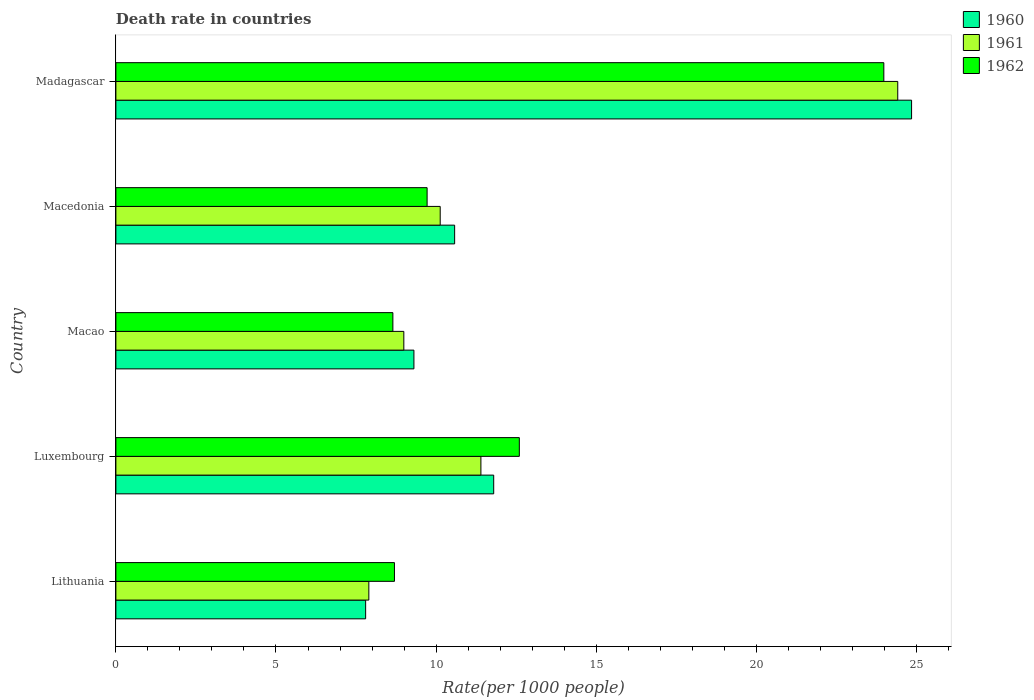Are the number of bars on each tick of the Y-axis equal?
Keep it short and to the point. Yes. How many bars are there on the 2nd tick from the top?
Your answer should be compact. 3. How many bars are there on the 4th tick from the bottom?
Give a very brief answer. 3. What is the label of the 2nd group of bars from the top?
Provide a short and direct response. Macedonia. In how many cases, is the number of bars for a given country not equal to the number of legend labels?
Offer a terse response. 0. What is the death rate in 1962 in Macao?
Offer a very short reply. 8.65. Across all countries, what is the maximum death rate in 1961?
Make the answer very short. 24.42. Across all countries, what is the minimum death rate in 1962?
Offer a very short reply. 8.65. In which country was the death rate in 1962 maximum?
Your answer should be very brief. Madagascar. In which country was the death rate in 1962 minimum?
Your answer should be compact. Macao. What is the total death rate in 1960 in the graph?
Your response must be concise. 64.34. What is the difference between the death rate in 1961 in Lithuania and that in Madagascar?
Offer a terse response. -16.52. What is the difference between the death rate in 1962 in Macao and the death rate in 1960 in Luxembourg?
Make the answer very short. -3.15. What is the average death rate in 1962 per country?
Your answer should be compact. 12.73. What is the difference between the death rate in 1962 and death rate in 1961 in Macedonia?
Make the answer very short. -0.41. In how many countries, is the death rate in 1962 greater than 3 ?
Offer a very short reply. 5. What is the ratio of the death rate in 1962 in Luxembourg to that in Madagascar?
Offer a terse response. 0.53. What is the difference between the highest and the second highest death rate in 1962?
Your response must be concise. 11.38. What is the difference between the highest and the lowest death rate in 1960?
Your answer should be very brief. 17.05. Is the sum of the death rate in 1961 in Luxembourg and Macedonia greater than the maximum death rate in 1962 across all countries?
Offer a terse response. No. What does the 1st bar from the bottom in Madagascar represents?
Ensure brevity in your answer.  1960. Is it the case that in every country, the sum of the death rate in 1960 and death rate in 1962 is greater than the death rate in 1961?
Ensure brevity in your answer.  Yes. How many bars are there?
Keep it short and to the point. 15. How many countries are there in the graph?
Ensure brevity in your answer.  5. What is the difference between two consecutive major ticks on the X-axis?
Your answer should be compact. 5. Are the values on the major ticks of X-axis written in scientific E-notation?
Provide a short and direct response. No. Does the graph contain any zero values?
Keep it short and to the point. No. Does the graph contain grids?
Keep it short and to the point. No. Where does the legend appear in the graph?
Your answer should be compact. Top right. What is the title of the graph?
Your answer should be very brief. Death rate in countries. Does "1962" appear as one of the legend labels in the graph?
Keep it short and to the point. Yes. What is the label or title of the X-axis?
Your response must be concise. Rate(per 1000 people). What is the label or title of the Y-axis?
Offer a terse response. Country. What is the Rate(per 1000 people) of 1961 in Lithuania?
Provide a succinct answer. 7.9. What is the Rate(per 1000 people) of 1960 in Luxembourg?
Offer a terse response. 11.8. What is the Rate(per 1000 people) in 1960 in Macao?
Provide a succinct answer. 9.31. What is the Rate(per 1000 people) in 1961 in Macao?
Your answer should be very brief. 8.99. What is the Rate(per 1000 people) in 1962 in Macao?
Ensure brevity in your answer.  8.65. What is the Rate(per 1000 people) of 1960 in Macedonia?
Your answer should be compact. 10.58. What is the Rate(per 1000 people) in 1961 in Macedonia?
Your answer should be compact. 10.13. What is the Rate(per 1000 people) of 1962 in Macedonia?
Ensure brevity in your answer.  9.72. What is the Rate(per 1000 people) in 1960 in Madagascar?
Ensure brevity in your answer.  24.85. What is the Rate(per 1000 people) of 1961 in Madagascar?
Provide a short and direct response. 24.42. What is the Rate(per 1000 people) in 1962 in Madagascar?
Make the answer very short. 23.98. Across all countries, what is the maximum Rate(per 1000 people) of 1960?
Offer a very short reply. 24.85. Across all countries, what is the maximum Rate(per 1000 people) in 1961?
Give a very brief answer. 24.42. Across all countries, what is the maximum Rate(per 1000 people) of 1962?
Provide a short and direct response. 23.98. Across all countries, what is the minimum Rate(per 1000 people) of 1960?
Your answer should be very brief. 7.8. Across all countries, what is the minimum Rate(per 1000 people) of 1961?
Offer a very short reply. 7.9. Across all countries, what is the minimum Rate(per 1000 people) of 1962?
Offer a very short reply. 8.65. What is the total Rate(per 1000 people) of 1960 in the graph?
Offer a terse response. 64.34. What is the total Rate(per 1000 people) in 1961 in the graph?
Provide a short and direct response. 62.84. What is the total Rate(per 1000 people) of 1962 in the graph?
Offer a very short reply. 63.66. What is the difference between the Rate(per 1000 people) in 1961 in Lithuania and that in Luxembourg?
Your response must be concise. -3.5. What is the difference between the Rate(per 1000 people) in 1960 in Lithuania and that in Macao?
Provide a succinct answer. -1.51. What is the difference between the Rate(per 1000 people) in 1961 in Lithuania and that in Macao?
Give a very brief answer. -1.09. What is the difference between the Rate(per 1000 people) of 1962 in Lithuania and that in Macao?
Your response must be concise. 0.05. What is the difference between the Rate(per 1000 people) of 1960 in Lithuania and that in Macedonia?
Provide a short and direct response. -2.78. What is the difference between the Rate(per 1000 people) in 1961 in Lithuania and that in Macedonia?
Your response must be concise. -2.23. What is the difference between the Rate(per 1000 people) in 1962 in Lithuania and that in Macedonia?
Offer a terse response. -1.02. What is the difference between the Rate(per 1000 people) in 1960 in Lithuania and that in Madagascar?
Make the answer very short. -17.05. What is the difference between the Rate(per 1000 people) of 1961 in Lithuania and that in Madagascar?
Give a very brief answer. -16.52. What is the difference between the Rate(per 1000 people) of 1962 in Lithuania and that in Madagascar?
Your answer should be compact. -15.28. What is the difference between the Rate(per 1000 people) in 1960 in Luxembourg and that in Macao?
Keep it short and to the point. 2.49. What is the difference between the Rate(per 1000 people) in 1961 in Luxembourg and that in Macao?
Offer a very short reply. 2.41. What is the difference between the Rate(per 1000 people) of 1962 in Luxembourg and that in Macao?
Keep it short and to the point. 3.95. What is the difference between the Rate(per 1000 people) of 1960 in Luxembourg and that in Macedonia?
Offer a very short reply. 1.22. What is the difference between the Rate(per 1000 people) in 1961 in Luxembourg and that in Macedonia?
Make the answer very short. 1.27. What is the difference between the Rate(per 1000 people) of 1962 in Luxembourg and that in Macedonia?
Provide a succinct answer. 2.88. What is the difference between the Rate(per 1000 people) in 1960 in Luxembourg and that in Madagascar?
Offer a terse response. -13.05. What is the difference between the Rate(per 1000 people) in 1961 in Luxembourg and that in Madagascar?
Your answer should be compact. -13.02. What is the difference between the Rate(per 1000 people) of 1962 in Luxembourg and that in Madagascar?
Your response must be concise. -11.38. What is the difference between the Rate(per 1000 people) of 1960 in Macao and that in Macedonia?
Your answer should be very brief. -1.27. What is the difference between the Rate(per 1000 people) of 1961 in Macao and that in Macedonia?
Provide a succinct answer. -1.14. What is the difference between the Rate(per 1000 people) of 1962 in Macao and that in Macedonia?
Offer a terse response. -1.07. What is the difference between the Rate(per 1000 people) in 1960 in Macao and that in Madagascar?
Your answer should be compact. -15.54. What is the difference between the Rate(per 1000 people) of 1961 in Macao and that in Madagascar?
Provide a short and direct response. -15.43. What is the difference between the Rate(per 1000 people) in 1962 in Macao and that in Madagascar?
Your answer should be compact. -15.33. What is the difference between the Rate(per 1000 people) of 1960 in Macedonia and that in Madagascar?
Ensure brevity in your answer.  -14.27. What is the difference between the Rate(per 1000 people) of 1961 in Macedonia and that in Madagascar?
Your response must be concise. -14.29. What is the difference between the Rate(per 1000 people) of 1962 in Macedonia and that in Madagascar?
Keep it short and to the point. -14.26. What is the difference between the Rate(per 1000 people) of 1960 in Lithuania and the Rate(per 1000 people) of 1961 in Luxembourg?
Provide a succinct answer. -3.6. What is the difference between the Rate(per 1000 people) in 1960 in Lithuania and the Rate(per 1000 people) in 1962 in Luxembourg?
Your answer should be compact. -4.8. What is the difference between the Rate(per 1000 people) in 1961 in Lithuania and the Rate(per 1000 people) in 1962 in Luxembourg?
Make the answer very short. -4.7. What is the difference between the Rate(per 1000 people) in 1960 in Lithuania and the Rate(per 1000 people) in 1961 in Macao?
Your answer should be compact. -1.19. What is the difference between the Rate(per 1000 people) in 1960 in Lithuania and the Rate(per 1000 people) in 1962 in Macao?
Give a very brief answer. -0.85. What is the difference between the Rate(per 1000 people) of 1961 in Lithuania and the Rate(per 1000 people) of 1962 in Macao?
Offer a terse response. -0.75. What is the difference between the Rate(per 1000 people) of 1960 in Lithuania and the Rate(per 1000 people) of 1961 in Macedonia?
Your response must be concise. -2.33. What is the difference between the Rate(per 1000 people) of 1960 in Lithuania and the Rate(per 1000 people) of 1962 in Macedonia?
Provide a succinct answer. -1.92. What is the difference between the Rate(per 1000 people) of 1961 in Lithuania and the Rate(per 1000 people) of 1962 in Macedonia?
Provide a short and direct response. -1.82. What is the difference between the Rate(per 1000 people) in 1960 in Lithuania and the Rate(per 1000 people) in 1961 in Madagascar?
Provide a succinct answer. -16.62. What is the difference between the Rate(per 1000 people) of 1960 in Lithuania and the Rate(per 1000 people) of 1962 in Madagascar?
Your answer should be very brief. -16.18. What is the difference between the Rate(per 1000 people) of 1961 in Lithuania and the Rate(per 1000 people) of 1962 in Madagascar?
Your answer should be very brief. -16.08. What is the difference between the Rate(per 1000 people) of 1960 in Luxembourg and the Rate(per 1000 people) of 1961 in Macao?
Ensure brevity in your answer.  2.81. What is the difference between the Rate(per 1000 people) of 1960 in Luxembourg and the Rate(per 1000 people) of 1962 in Macao?
Your response must be concise. 3.15. What is the difference between the Rate(per 1000 people) of 1961 in Luxembourg and the Rate(per 1000 people) of 1962 in Macao?
Provide a short and direct response. 2.75. What is the difference between the Rate(per 1000 people) of 1960 in Luxembourg and the Rate(per 1000 people) of 1961 in Macedonia?
Provide a short and direct response. 1.67. What is the difference between the Rate(per 1000 people) of 1960 in Luxembourg and the Rate(per 1000 people) of 1962 in Macedonia?
Offer a very short reply. 2.08. What is the difference between the Rate(per 1000 people) of 1961 in Luxembourg and the Rate(per 1000 people) of 1962 in Macedonia?
Your answer should be very brief. 1.68. What is the difference between the Rate(per 1000 people) in 1960 in Luxembourg and the Rate(per 1000 people) in 1961 in Madagascar?
Your answer should be very brief. -12.62. What is the difference between the Rate(per 1000 people) of 1960 in Luxembourg and the Rate(per 1000 people) of 1962 in Madagascar?
Provide a succinct answer. -12.18. What is the difference between the Rate(per 1000 people) in 1961 in Luxembourg and the Rate(per 1000 people) in 1962 in Madagascar?
Ensure brevity in your answer.  -12.58. What is the difference between the Rate(per 1000 people) in 1960 in Macao and the Rate(per 1000 people) in 1961 in Macedonia?
Make the answer very short. -0.82. What is the difference between the Rate(per 1000 people) of 1960 in Macao and the Rate(per 1000 people) of 1962 in Macedonia?
Offer a very short reply. -0.41. What is the difference between the Rate(per 1000 people) in 1961 in Macao and the Rate(per 1000 people) in 1962 in Macedonia?
Offer a very short reply. -0.73. What is the difference between the Rate(per 1000 people) of 1960 in Macao and the Rate(per 1000 people) of 1961 in Madagascar?
Offer a terse response. -15.11. What is the difference between the Rate(per 1000 people) of 1960 in Macao and the Rate(per 1000 people) of 1962 in Madagascar?
Provide a succinct answer. -14.68. What is the difference between the Rate(per 1000 people) in 1961 in Macao and the Rate(per 1000 people) in 1962 in Madagascar?
Your answer should be compact. -14.99. What is the difference between the Rate(per 1000 people) in 1960 in Macedonia and the Rate(per 1000 people) in 1961 in Madagascar?
Your response must be concise. -13.84. What is the difference between the Rate(per 1000 people) of 1960 in Macedonia and the Rate(per 1000 people) of 1962 in Madagascar?
Keep it short and to the point. -13.4. What is the difference between the Rate(per 1000 people) of 1961 in Macedonia and the Rate(per 1000 people) of 1962 in Madagascar?
Your response must be concise. -13.86. What is the average Rate(per 1000 people) of 1960 per country?
Provide a short and direct response. 12.87. What is the average Rate(per 1000 people) of 1961 per country?
Ensure brevity in your answer.  12.57. What is the average Rate(per 1000 people) of 1962 per country?
Your answer should be very brief. 12.73. What is the difference between the Rate(per 1000 people) of 1960 and Rate(per 1000 people) of 1961 in Luxembourg?
Keep it short and to the point. 0.4. What is the difference between the Rate(per 1000 people) of 1960 and Rate(per 1000 people) of 1961 in Macao?
Provide a succinct answer. 0.32. What is the difference between the Rate(per 1000 people) in 1960 and Rate(per 1000 people) in 1962 in Macao?
Provide a short and direct response. 0.66. What is the difference between the Rate(per 1000 people) in 1961 and Rate(per 1000 people) in 1962 in Macao?
Ensure brevity in your answer.  0.34. What is the difference between the Rate(per 1000 people) in 1960 and Rate(per 1000 people) in 1961 in Macedonia?
Your answer should be very brief. 0.45. What is the difference between the Rate(per 1000 people) in 1960 and Rate(per 1000 people) in 1962 in Macedonia?
Your response must be concise. 0.86. What is the difference between the Rate(per 1000 people) of 1961 and Rate(per 1000 people) of 1962 in Macedonia?
Offer a terse response. 0.41. What is the difference between the Rate(per 1000 people) of 1960 and Rate(per 1000 people) of 1961 in Madagascar?
Ensure brevity in your answer.  0.43. What is the difference between the Rate(per 1000 people) of 1960 and Rate(per 1000 people) of 1962 in Madagascar?
Provide a succinct answer. 0.87. What is the difference between the Rate(per 1000 people) of 1961 and Rate(per 1000 people) of 1962 in Madagascar?
Give a very brief answer. 0.43. What is the ratio of the Rate(per 1000 people) of 1960 in Lithuania to that in Luxembourg?
Your answer should be very brief. 0.66. What is the ratio of the Rate(per 1000 people) of 1961 in Lithuania to that in Luxembourg?
Your response must be concise. 0.69. What is the ratio of the Rate(per 1000 people) of 1962 in Lithuania to that in Luxembourg?
Your answer should be compact. 0.69. What is the ratio of the Rate(per 1000 people) of 1960 in Lithuania to that in Macao?
Provide a succinct answer. 0.84. What is the ratio of the Rate(per 1000 people) in 1961 in Lithuania to that in Macao?
Your answer should be very brief. 0.88. What is the ratio of the Rate(per 1000 people) of 1960 in Lithuania to that in Macedonia?
Your answer should be compact. 0.74. What is the ratio of the Rate(per 1000 people) in 1961 in Lithuania to that in Macedonia?
Make the answer very short. 0.78. What is the ratio of the Rate(per 1000 people) of 1962 in Lithuania to that in Macedonia?
Your response must be concise. 0.9. What is the ratio of the Rate(per 1000 people) in 1960 in Lithuania to that in Madagascar?
Your answer should be compact. 0.31. What is the ratio of the Rate(per 1000 people) in 1961 in Lithuania to that in Madagascar?
Your response must be concise. 0.32. What is the ratio of the Rate(per 1000 people) of 1962 in Lithuania to that in Madagascar?
Offer a very short reply. 0.36. What is the ratio of the Rate(per 1000 people) in 1960 in Luxembourg to that in Macao?
Give a very brief answer. 1.27. What is the ratio of the Rate(per 1000 people) in 1961 in Luxembourg to that in Macao?
Your answer should be very brief. 1.27. What is the ratio of the Rate(per 1000 people) of 1962 in Luxembourg to that in Macao?
Offer a terse response. 1.46. What is the ratio of the Rate(per 1000 people) of 1960 in Luxembourg to that in Macedonia?
Your answer should be compact. 1.12. What is the ratio of the Rate(per 1000 people) of 1961 in Luxembourg to that in Macedonia?
Offer a very short reply. 1.13. What is the ratio of the Rate(per 1000 people) in 1962 in Luxembourg to that in Macedonia?
Your answer should be very brief. 1.3. What is the ratio of the Rate(per 1000 people) of 1960 in Luxembourg to that in Madagascar?
Make the answer very short. 0.47. What is the ratio of the Rate(per 1000 people) in 1961 in Luxembourg to that in Madagascar?
Keep it short and to the point. 0.47. What is the ratio of the Rate(per 1000 people) of 1962 in Luxembourg to that in Madagascar?
Your response must be concise. 0.53. What is the ratio of the Rate(per 1000 people) in 1960 in Macao to that in Macedonia?
Make the answer very short. 0.88. What is the ratio of the Rate(per 1000 people) of 1961 in Macao to that in Macedonia?
Give a very brief answer. 0.89. What is the ratio of the Rate(per 1000 people) of 1962 in Macao to that in Macedonia?
Give a very brief answer. 0.89. What is the ratio of the Rate(per 1000 people) in 1960 in Macao to that in Madagascar?
Offer a terse response. 0.37. What is the ratio of the Rate(per 1000 people) of 1961 in Macao to that in Madagascar?
Your answer should be very brief. 0.37. What is the ratio of the Rate(per 1000 people) in 1962 in Macao to that in Madagascar?
Provide a succinct answer. 0.36. What is the ratio of the Rate(per 1000 people) of 1960 in Macedonia to that in Madagascar?
Give a very brief answer. 0.43. What is the ratio of the Rate(per 1000 people) of 1961 in Macedonia to that in Madagascar?
Provide a succinct answer. 0.41. What is the ratio of the Rate(per 1000 people) of 1962 in Macedonia to that in Madagascar?
Give a very brief answer. 0.41. What is the difference between the highest and the second highest Rate(per 1000 people) of 1960?
Ensure brevity in your answer.  13.05. What is the difference between the highest and the second highest Rate(per 1000 people) of 1961?
Keep it short and to the point. 13.02. What is the difference between the highest and the second highest Rate(per 1000 people) in 1962?
Your response must be concise. 11.38. What is the difference between the highest and the lowest Rate(per 1000 people) of 1960?
Make the answer very short. 17.05. What is the difference between the highest and the lowest Rate(per 1000 people) in 1961?
Your response must be concise. 16.52. What is the difference between the highest and the lowest Rate(per 1000 people) in 1962?
Offer a terse response. 15.33. 